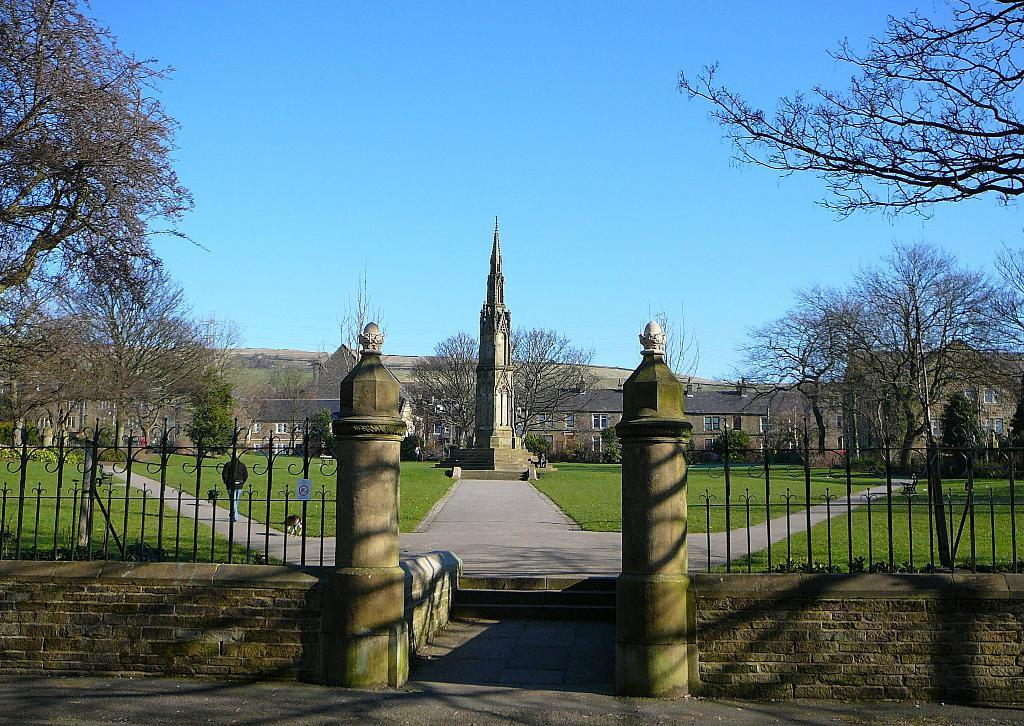What is visible at the top of the image? The sky, trees, hills, and buildings are visible at the top of the image. What is located at the bottom of the image? A tower, pedestal, roads, ground, walls, an iron grill, and poles are visible at the bottom of the image. What type of insurance is being offered by the guide in the image? There is no guide or insurance present in the image. How long does it take to walk from the tower to the hills in the image? The image does not provide information about the distance or time it takes to walk between the tower and the hills. 